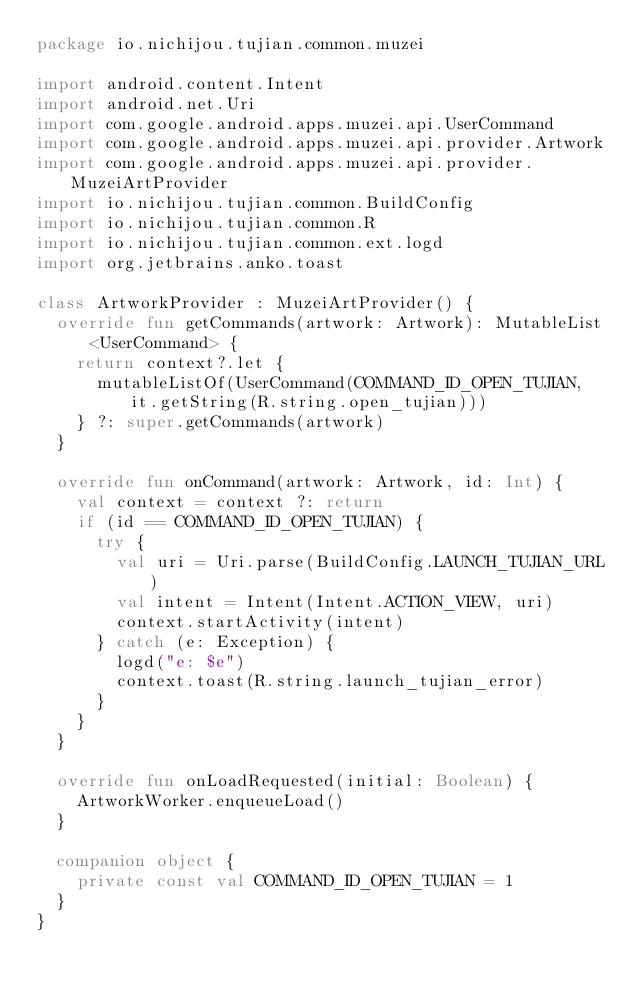<code> <loc_0><loc_0><loc_500><loc_500><_Kotlin_>package io.nichijou.tujian.common.muzei

import android.content.Intent
import android.net.Uri
import com.google.android.apps.muzei.api.UserCommand
import com.google.android.apps.muzei.api.provider.Artwork
import com.google.android.apps.muzei.api.provider.MuzeiArtProvider
import io.nichijou.tujian.common.BuildConfig
import io.nichijou.tujian.common.R
import io.nichijou.tujian.common.ext.logd
import org.jetbrains.anko.toast

class ArtworkProvider : MuzeiArtProvider() {
  override fun getCommands(artwork: Artwork): MutableList<UserCommand> {
    return context?.let {
      mutableListOf(UserCommand(COMMAND_ID_OPEN_TUJIAN, it.getString(R.string.open_tujian)))
    } ?: super.getCommands(artwork)
  }

  override fun onCommand(artwork: Artwork, id: Int) {
    val context = context ?: return
    if (id == COMMAND_ID_OPEN_TUJIAN) {
      try {
        val uri = Uri.parse(BuildConfig.LAUNCH_TUJIAN_URL)
        val intent = Intent(Intent.ACTION_VIEW, uri)
        context.startActivity(intent)
      } catch (e: Exception) {
        logd("e: $e")
        context.toast(R.string.launch_tujian_error)
      }
    }
  }

  override fun onLoadRequested(initial: Boolean) {
    ArtworkWorker.enqueueLoad()
  }

  companion object {
    private const val COMMAND_ID_OPEN_TUJIAN = 1
  }
}
</code> 